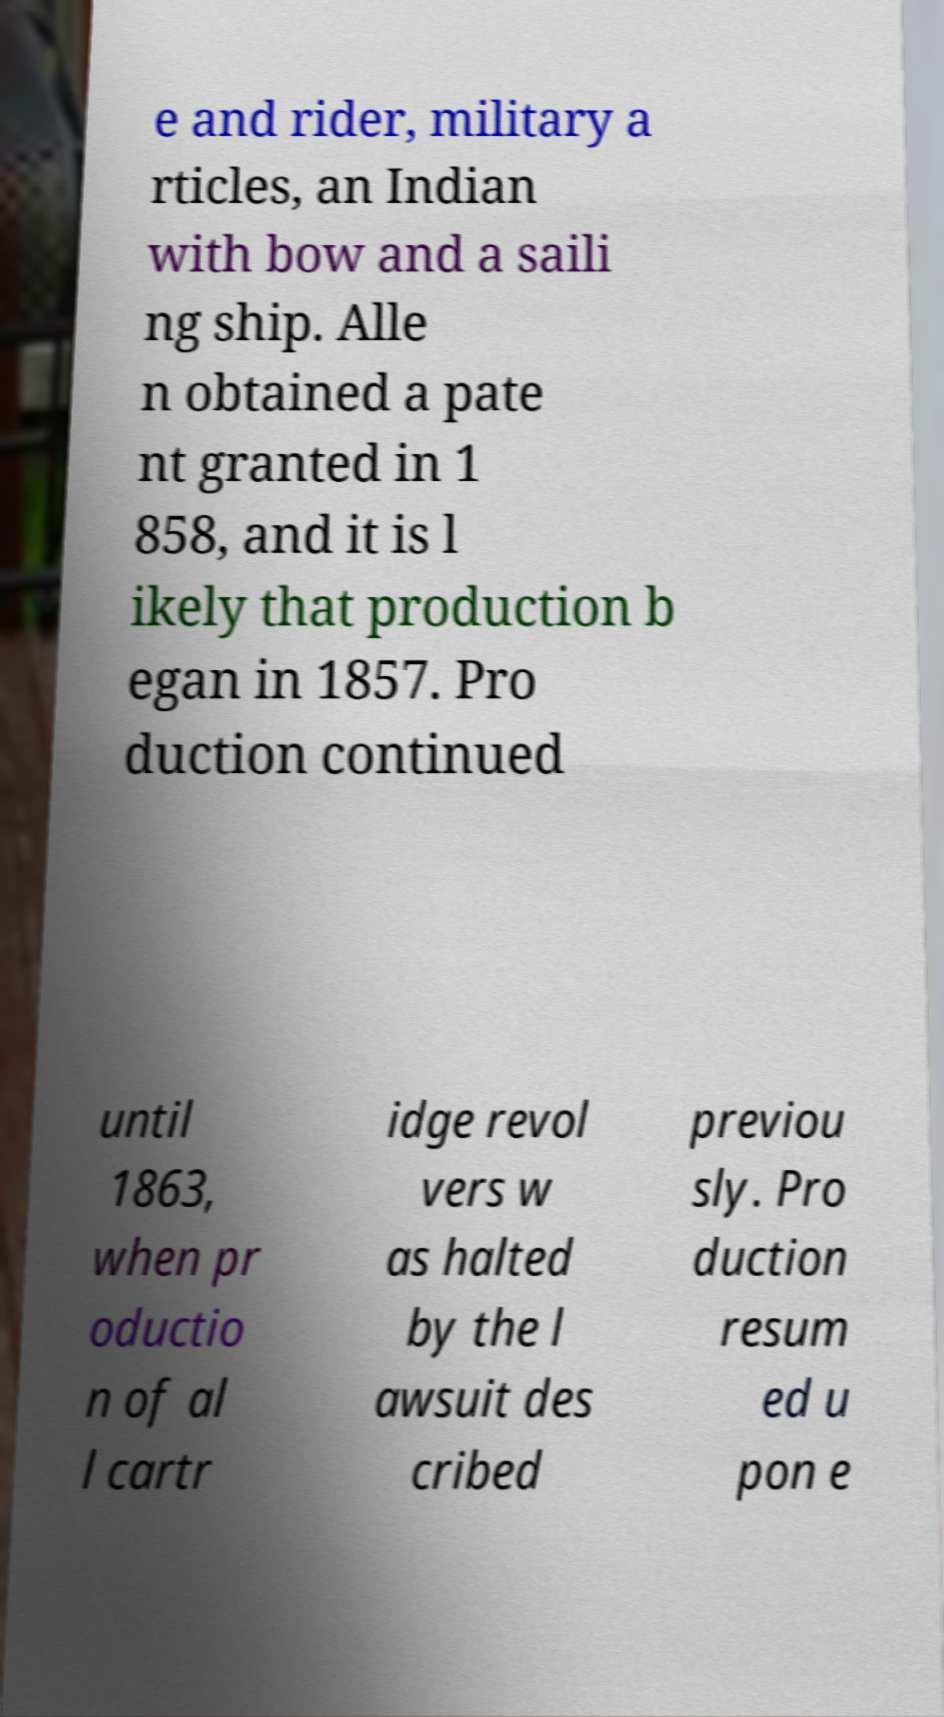Can you accurately transcribe the text from the provided image for me? e and rider, military a rticles, an Indian with bow and a saili ng ship. Alle n obtained a pate nt granted in 1 858, and it is l ikely that production b egan in 1857. Pro duction continued until 1863, when pr oductio n of al l cartr idge revol vers w as halted by the l awsuit des cribed previou sly. Pro duction resum ed u pon e 